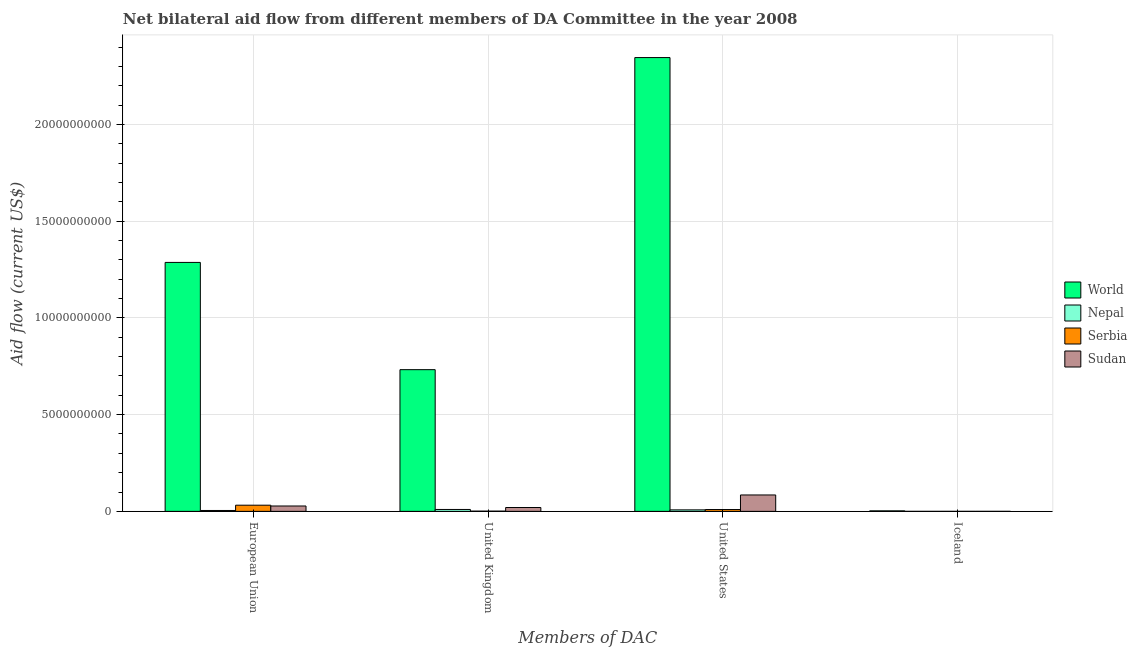How many groups of bars are there?
Your response must be concise. 4. Are the number of bars per tick equal to the number of legend labels?
Provide a succinct answer. Yes. How many bars are there on the 4th tick from the left?
Your answer should be compact. 4. What is the amount of aid given by uk in Sudan?
Your answer should be compact. 1.99e+08. Across all countries, what is the maximum amount of aid given by eu?
Your response must be concise. 1.29e+1. Across all countries, what is the minimum amount of aid given by uk?
Provide a short and direct response. 1.20e+07. In which country was the amount of aid given by uk maximum?
Your answer should be very brief. World. In which country was the amount of aid given by eu minimum?
Keep it short and to the point. Nepal. What is the total amount of aid given by us in the graph?
Keep it short and to the point. 2.45e+1. What is the difference between the amount of aid given by eu in Sudan and that in World?
Make the answer very short. -1.26e+1. What is the difference between the amount of aid given by iceland in World and the amount of aid given by us in Serbia?
Offer a very short reply. -6.80e+07. What is the average amount of aid given by uk per country?
Your answer should be very brief. 1.91e+09. What is the difference between the amount of aid given by us and amount of aid given by iceland in World?
Your response must be concise. 2.34e+1. What is the ratio of the amount of aid given by eu in World to that in Serbia?
Make the answer very short. 40.33. Is the amount of aid given by iceland in Serbia less than that in Nepal?
Provide a short and direct response. No. What is the difference between the highest and the second highest amount of aid given by iceland?
Offer a terse response. 2.61e+07. What is the difference between the highest and the lowest amount of aid given by uk?
Your response must be concise. 7.31e+09. What does the 3rd bar from the right in Iceland represents?
Provide a short and direct response. Nepal. Is it the case that in every country, the sum of the amount of aid given by eu and amount of aid given by uk is greater than the amount of aid given by us?
Your answer should be compact. No. How many bars are there?
Ensure brevity in your answer.  16. Are all the bars in the graph horizontal?
Your response must be concise. No. How many countries are there in the graph?
Make the answer very short. 4. What is the difference between two consecutive major ticks on the Y-axis?
Provide a succinct answer. 5.00e+09. Does the graph contain any zero values?
Provide a short and direct response. No. Does the graph contain grids?
Provide a short and direct response. Yes. Where does the legend appear in the graph?
Offer a terse response. Center right. How many legend labels are there?
Make the answer very short. 4. What is the title of the graph?
Give a very brief answer. Net bilateral aid flow from different members of DA Committee in the year 2008. What is the label or title of the X-axis?
Ensure brevity in your answer.  Members of DAC. What is the Aid flow (current US$) of World in European Union?
Your response must be concise. 1.29e+1. What is the Aid flow (current US$) of Nepal in European Union?
Provide a succinct answer. 4.62e+07. What is the Aid flow (current US$) of Serbia in European Union?
Provide a succinct answer. 3.19e+08. What is the Aid flow (current US$) of Sudan in European Union?
Keep it short and to the point. 2.78e+08. What is the Aid flow (current US$) of World in United Kingdom?
Your answer should be compact. 7.32e+09. What is the Aid flow (current US$) of Nepal in United Kingdom?
Your answer should be very brief. 9.86e+07. What is the Aid flow (current US$) of Serbia in United Kingdom?
Your answer should be very brief. 1.20e+07. What is the Aid flow (current US$) in Sudan in United Kingdom?
Provide a succinct answer. 1.99e+08. What is the Aid flow (current US$) in World in United States?
Keep it short and to the point. 2.35e+1. What is the Aid flow (current US$) in Nepal in United States?
Provide a succinct answer. 7.76e+07. What is the Aid flow (current US$) of Serbia in United States?
Keep it short and to the point. 9.45e+07. What is the Aid flow (current US$) in Sudan in United States?
Provide a succinct answer. 8.48e+08. What is the Aid flow (current US$) of World in Iceland?
Keep it short and to the point. 2.65e+07. What is the Aid flow (current US$) of Serbia in Iceland?
Ensure brevity in your answer.  3.20e+05. Across all Members of DAC, what is the maximum Aid flow (current US$) of World?
Give a very brief answer. 2.35e+1. Across all Members of DAC, what is the maximum Aid flow (current US$) of Nepal?
Make the answer very short. 9.86e+07. Across all Members of DAC, what is the maximum Aid flow (current US$) of Serbia?
Give a very brief answer. 3.19e+08. Across all Members of DAC, what is the maximum Aid flow (current US$) in Sudan?
Offer a very short reply. 8.48e+08. Across all Members of DAC, what is the minimum Aid flow (current US$) of World?
Your answer should be compact. 2.65e+07. Across all Members of DAC, what is the minimum Aid flow (current US$) of Nepal?
Offer a terse response. 5.00e+04. Across all Members of DAC, what is the minimum Aid flow (current US$) of Serbia?
Provide a succinct answer. 3.20e+05. What is the total Aid flow (current US$) in World in the graph?
Offer a terse response. 4.37e+1. What is the total Aid flow (current US$) in Nepal in the graph?
Your answer should be compact. 2.22e+08. What is the total Aid flow (current US$) in Serbia in the graph?
Give a very brief answer. 4.26e+08. What is the total Aid flow (current US$) in Sudan in the graph?
Give a very brief answer. 1.33e+09. What is the difference between the Aid flow (current US$) of World in European Union and that in United Kingdom?
Give a very brief answer. 5.54e+09. What is the difference between the Aid flow (current US$) in Nepal in European Union and that in United Kingdom?
Your response must be concise. -5.25e+07. What is the difference between the Aid flow (current US$) in Serbia in European Union and that in United Kingdom?
Make the answer very short. 3.07e+08. What is the difference between the Aid flow (current US$) in Sudan in European Union and that in United Kingdom?
Offer a very short reply. 7.87e+07. What is the difference between the Aid flow (current US$) of World in European Union and that in United States?
Make the answer very short. -1.06e+1. What is the difference between the Aid flow (current US$) of Nepal in European Union and that in United States?
Ensure brevity in your answer.  -3.15e+07. What is the difference between the Aid flow (current US$) in Serbia in European Union and that in United States?
Provide a short and direct response. 2.25e+08. What is the difference between the Aid flow (current US$) in Sudan in European Union and that in United States?
Your answer should be very brief. -5.70e+08. What is the difference between the Aid flow (current US$) in World in European Union and that in Iceland?
Provide a short and direct response. 1.28e+1. What is the difference between the Aid flow (current US$) of Nepal in European Union and that in Iceland?
Make the answer very short. 4.61e+07. What is the difference between the Aid flow (current US$) in Serbia in European Union and that in Iceland?
Your response must be concise. 3.19e+08. What is the difference between the Aid flow (current US$) in Sudan in European Union and that in Iceland?
Make the answer very short. 2.77e+08. What is the difference between the Aid flow (current US$) in World in United Kingdom and that in United States?
Provide a succinct answer. -1.61e+1. What is the difference between the Aid flow (current US$) in Nepal in United Kingdom and that in United States?
Offer a terse response. 2.10e+07. What is the difference between the Aid flow (current US$) in Serbia in United Kingdom and that in United States?
Your answer should be compact. -8.24e+07. What is the difference between the Aid flow (current US$) of Sudan in United Kingdom and that in United States?
Keep it short and to the point. -6.49e+08. What is the difference between the Aid flow (current US$) in World in United Kingdom and that in Iceland?
Your answer should be compact. 7.30e+09. What is the difference between the Aid flow (current US$) of Nepal in United Kingdom and that in Iceland?
Make the answer very short. 9.86e+07. What is the difference between the Aid flow (current US$) of Serbia in United Kingdom and that in Iceland?
Provide a short and direct response. 1.17e+07. What is the difference between the Aid flow (current US$) of Sudan in United Kingdom and that in Iceland?
Provide a succinct answer. 1.99e+08. What is the difference between the Aid flow (current US$) of World in United States and that in Iceland?
Your answer should be very brief. 2.34e+1. What is the difference between the Aid flow (current US$) in Nepal in United States and that in Iceland?
Offer a very short reply. 7.76e+07. What is the difference between the Aid flow (current US$) of Serbia in United States and that in Iceland?
Offer a terse response. 9.42e+07. What is the difference between the Aid flow (current US$) in Sudan in United States and that in Iceland?
Offer a very short reply. 8.48e+08. What is the difference between the Aid flow (current US$) in World in European Union and the Aid flow (current US$) in Nepal in United Kingdom?
Offer a terse response. 1.28e+1. What is the difference between the Aid flow (current US$) of World in European Union and the Aid flow (current US$) of Serbia in United Kingdom?
Provide a short and direct response. 1.29e+1. What is the difference between the Aid flow (current US$) in World in European Union and the Aid flow (current US$) in Sudan in United Kingdom?
Provide a short and direct response. 1.27e+1. What is the difference between the Aid flow (current US$) in Nepal in European Union and the Aid flow (current US$) in Serbia in United Kingdom?
Your response must be concise. 3.41e+07. What is the difference between the Aid flow (current US$) of Nepal in European Union and the Aid flow (current US$) of Sudan in United Kingdom?
Keep it short and to the point. -1.53e+08. What is the difference between the Aid flow (current US$) in Serbia in European Union and the Aid flow (current US$) in Sudan in United Kingdom?
Offer a very short reply. 1.20e+08. What is the difference between the Aid flow (current US$) in World in European Union and the Aid flow (current US$) in Nepal in United States?
Make the answer very short. 1.28e+1. What is the difference between the Aid flow (current US$) in World in European Union and the Aid flow (current US$) in Serbia in United States?
Give a very brief answer. 1.28e+1. What is the difference between the Aid flow (current US$) of World in European Union and the Aid flow (current US$) of Sudan in United States?
Your response must be concise. 1.20e+1. What is the difference between the Aid flow (current US$) of Nepal in European Union and the Aid flow (current US$) of Serbia in United States?
Your response must be concise. -4.83e+07. What is the difference between the Aid flow (current US$) in Nepal in European Union and the Aid flow (current US$) in Sudan in United States?
Give a very brief answer. -8.02e+08. What is the difference between the Aid flow (current US$) in Serbia in European Union and the Aid flow (current US$) in Sudan in United States?
Ensure brevity in your answer.  -5.29e+08. What is the difference between the Aid flow (current US$) in World in European Union and the Aid flow (current US$) in Nepal in Iceland?
Keep it short and to the point. 1.29e+1. What is the difference between the Aid flow (current US$) in World in European Union and the Aid flow (current US$) in Serbia in Iceland?
Ensure brevity in your answer.  1.29e+1. What is the difference between the Aid flow (current US$) in World in European Union and the Aid flow (current US$) in Sudan in Iceland?
Offer a very short reply. 1.29e+1. What is the difference between the Aid flow (current US$) in Nepal in European Union and the Aid flow (current US$) in Serbia in Iceland?
Make the answer very short. 4.58e+07. What is the difference between the Aid flow (current US$) of Nepal in European Union and the Aid flow (current US$) of Sudan in Iceland?
Give a very brief answer. 4.58e+07. What is the difference between the Aid flow (current US$) of Serbia in European Union and the Aid flow (current US$) of Sudan in Iceland?
Make the answer very short. 3.19e+08. What is the difference between the Aid flow (current US$) of World in United Kingdom and the Aid flow (current US$) of Nepal in United States?
Provide a short and direct response. 7.25e+09. What is the difference between the Aid flow (current US$) of World in United Kingdom and the Aid flow (current US$) of Serbia in United States?
Provide a short and direct response. 7.23e+09. What is the difference between the Aid flow (current US$) in World in United Kingdom and the Aid flow (current US$) in Sudan in United States?
Provide a succinct answer. 6.48e+09. What is the difference between the Aid flow (current US$) in Nepal in United Kingdom and the Aid flow (current US$) in Serbia in United States?
Offer a terse response. 4.15e+06. What is the difference between the Aid flow (current US$) of Nepal in United Kingdom and the Aid flow (current US$) of Sudan in United States?
Ensure brevity in your answer.  -7.50e+08. What is the difference between the Aid flow (current US$) in Serbia in United Kingdom and the Aid flow (current US$) in Sudan in United States?
Offer a terse response. -8.36e+08. What is the difference between the Aid flow (current US$) of World in United Kingdom and the Aid flow (current US$) of Nepal in Iceland?
Your response must be concise. 7.32e+09. What is the difference between the Aid flow (current US$) in World in United Kingdom and the Aid flow (current US$) in Serbia in Iceland?
Make the answer very short. 7.32e+09. What is the difference between the Aid flow (current US$) of World in United Kingdom and the Aid flow (current US$) of Sudan in Iceland?
Provide a succinct answer. 7.32e+09. What is the difference between the Aid flow (current US$) in Nepal in United Kingdom and the Aid flow (current US$) in Serbia in Iceland?
Offer a very short reply. 9.83e+07. What is the difference between the Aid flow (current US$) in Nepal in United Kingdom and the Aid flow (current US$) in Sudan in Iceland?
Your response must be concise. 9.82e+07. What is the difference between the Aid flow (current US$) of Serbia in United Kingdom and the Aid flow (current US$) of Sudan in Iceland?
Your answer should be very brief. 1.16e+07. What is the difference between the Aid flow (current US$) of World in United States and the Aid flow (current US$) of Nepal in Iceland?
Your answer should be very brief. 2.35e+1. What is the difference between the Aid flow (current US$) in World in United States and the Aid flow (current US$) in Serbia in Iceland?
Your response must be concise. 2.35e+1. What is the difference between the Aid flow (current US$) of World in United States and the Aid flow (current US$) of Sudan in Iceland?
Provide a succinct answer. 2.35e+1. What is the difference between the Aid flow (current US$) in Nepal in United States and the Aid flow (current US$) in Serbia in Iceland?
Ensure brevity in your answer.  7.73e+07. What is the difference between the Aid flow (current US$) in Nepal in United States and the Aid flow (current US$) in Sudan in Iceland?
Your answer should be compact. 7.72e+07. What is the difference between the Aid flow (current US$) in Serbia in United States and the Aid flow (current US$) in Sudan in Iceland?
Offer a terse response. 9.41e+07. What is the average Aid flow (current US$) of World per Members of DAC?
Provide a short and direct response. 1.09e+1. What is the average Aid flow (current US$) in Nepal per Members of DAC?
Make the answer very short. 5.56e+07. What is the average Aid flow (current US$) of Serbia per Members of DAC?
Provide a succinct answer. 1.06e+08. What is the average Aid flow (current US$) of Sudan per Members of DAC?
Keep it short and to the point. 3.31e+08. What is the difference between the Aid flow (current US$) of World and Aid flow (current US$) of Nepal in European Union?
Provide a short and direct response. 1.28e+1. What is the difference between the Aid flow (current US$) in World and Aid flow (current US$) in Serbia in European Union?
Your answer should be very brief. 1.25e+1. What is the difference between the Aid flow (current US$) in World and Aid flow (current US$) in Sudan in European Union?
Provide a short and direct response. 1.26e+1. What is the difference between the Aid flow (current US$) in Nepal and Aid flow (current US$) in Serbia in European Union?
Provide a short and direct response. -2.73e+08. What is the difference between the Aid flow (current US$) of Nepal and Aid flow (current US$) of Sudan in European Union?
Give a very brief answer. -2.32e+08. What is the difference between the Aid flow (current US$) of Serbia and Aid flow (current US$) of Sudan in European Union?
Ensure brevity in your answer.  4.12e+07. What is the difference between the Aid flow (current US$) in World and Aid flow (current US$) in Nepal in United Kingdom?
Provide a short and direct response. 7.22e+09. What is the difference between the Aid flow (current US$) of World and Aid flow (current US$) of Serbia in United Kingdom?
Keep it short and to the point. 7.31e+09. What is the difference between the Aid flow (current US$) of World and Aid flow (current US$) of Sudan in United Kingdom?
Provide a short and direct response. 7.12e+09. What is the difference between the Aid flow (current US$) of Nepal and Aid flow (current US$) of Serbia in United Kingdom?
Ensure brevity in your answer.  8.66e+07. What is the difference between the Aid flow (current US$) of Nepal and Aid flow (current US$) of Sudan in United Kingdom?
Provide a succinct answer. -1.01e+08. What is the difference between the Aid flow (current US$) in Serbia and Aid flow (current US$) in Sudan in United Kingdom?
Provide a succinct answer. -1.87e+08. What is the difference between the Aid flow (current US$) of World and Aid flow (current US$) of Nepal in United States?
Your answer should be compact. 2.34e+1. What is the difference between the Aid flow (current US$) of World and Aid flow (current US$) of Serbia in United States?
Keep it short and to the point. 2.34e+1. What is the difference between the Aid flow (current US$) in World and Aid flow (current US$) in Sudan in United States?
Your answer should be compact. 2.26e+1. What is the difference between the Aid flow (current US$) in Nepal and Aid flow (current US$) in Serbia in United States?
Keep it short and to the point. -1.68e+07. What is the difference between the Aid flow (current US$) of Nepal and Aid flow (current US$) of Sudan in United States?
Offer a very short reply. -7.71e+08. What is the difference between the Aid flow (current US$) in Serbia and Aid flow (current US$) in Sudan in United States?
Give a very brief answer. -7.54e+08. What is the difference between the Aid flow (current US$) in World and Aid flow (current US$) in Nepal in Iceland?
Make the answer very short. 2.64e+07. What is the difference between the Aid flow (current US$) of World and Aid flow (current US$) of Serbia in Iceland?
Provide a succinct answer. 2.62e+07. What is the difference between the Aid flow (current US$) of World and Aid flow (current US$) of Sudan in Iceland?
Your answer should be very brief. 2.61e+07. What is the difference between the Aid flow (current US$) of Nepal and Aid flow (current US$) of Serbia in Iceland?
Your answer should be very brief. -2.70e+05. What is the difference between the Aid flow (current US$) of Nepal and Aid flow (current US$) of Sudan in Iceland?
Provide a short and direct response. -3.60e+05. What is the ratio of the Aid flow (current US$) in World in European Union to that in United Kingdom?
Your response must be concise. 1.76. What is the ratio of the Aid flow (current US$) in Nepal in European Union to that in United Kingdom?
Your answer should be very brief. 0.47. What is the ratio of the Aid flow (current US$) in Serbia in European Union to that in United Kingdom?
Provide a short and direct response. 26.47. What is the ratio of the Aid flow (current US$) in Sudan in European Union to that in United Kingdom?
Provide a succinct answer. 1.4. What is the ratio of the Aid flow (current US$) in World in European Union to that in United States?
Your response must be concise. 0.55. What is the ratio of the Aid flow (current US$) of Nepal in European Union to that in United States?
Give a very brief answer. 0.59. What is the ratio of the Aid flow (current US$) in Serbia in European Union to that in United States?
Your answer should be very brief. 3.38. What is the ratio of the Aid flow (current US$) of Sudan in European Union to that in United States?
Give a very brief answer. 0.33. What is the ratio of the Aid flow (current US$) of World in European Union to that in Iceland?
Offer a very short reply. 485.74. What is the ratio of the Aid flow (current US$) of Nepal in European Union to that in Iceland?
Keep it short and to the point. 923.2. What is the ratio of the Aid flow (current US$) of Serbia in European Union to that in Iceland?
Keep it short and to the point. 996.94. What is the ratio of the Aid flow (current US$) of Sudan in European Union to that in Iceland?
Provide a succinct answer. 677.66. What is the ratio of the Aid flow (current US$) in World in United Kingdom to that in United States?
Your answer should be compact. 0.31. What is the ratio of the Aid flow (current US$) in Nepal in United Kingdom to that in United States?
Your answer should be compact. 1.27. What is the ratio of the Aid flow (current US$) in Serbia in United Kingdom to that in United States?
Give a very brief answer. 0.13. What is the ratio of the Aid flow (current US$) in Sudan in United Kingdom to that in United States?
Keep it short and to the point. 0.23. What is the ratio of the Aid flow (current US$) of World in United Kingdom to that in Iceland?
Provide a short and direct response. 276.46. What is the ratio of the Aid flow (current US$) in Nepal in United Kingdom to that in Iceland?
Give a very brief answer. 1972.4. What is the ratio of the Aid flow (current US$) of Serbia in United Kingdom to that in Iceland?
Offer a very short reply. 37.66. What is the ratio of the Aid flow (current US$) of Sudan in United Kingdom to that in Iceland?
Give a very brief answer. 485.76. What is the ratio of the Aid flow (current US$) of World in United States to that in Iceland?
Give a very brief answer. 885.41. What is the ratio of the Aid flow (current US$) of Nepal in United States to that in Iceland?
Provide a short and direct response. 1553. What is the ratio of the Aid flow (current US$) of Serbia in United States to that in Iceland?
Offer a very short reply. 295.22. What is the ratio of the Aid flow (current US$) in Sudan in United States to that in Iceland?
Make the answer very short. 2068.68. What is the difference between the highest and the second highest Aid flow (current US$) of World?
Ensure brevity in your answer.  1.06e+1. What is the difference between the highest and the second highest Aid flow (current US$) of Nepal?
Your answer should be compact. 2.10e+07. What is the difference between the highest and the second highest Aid flow (current US$) in Serbia?
Offer a very short reply. 2.25e+08. What is the difference between the highest and the second highest Aid flow (current US$) in Sudan?
Your response must be concise. 5.70e+08. What is the difference between the highest and the lowest Aid flow (current US$) of World?
Ensure brevity in your answer.  2.34e+1. What is the difference between the highest and the lowest Aid flow (current US$) of Nepal?
Ensure brevity in your answer.  9.86e+07. What is the difference between the highest and the lowest Aid flow (current US$) of Serbia?
Give a very brief answer. 3.19e+08. What is the difference between the highest and the lowest Aid flow (current US$) of Sudan?
Provide a short and direct response. 8.48e+08. 